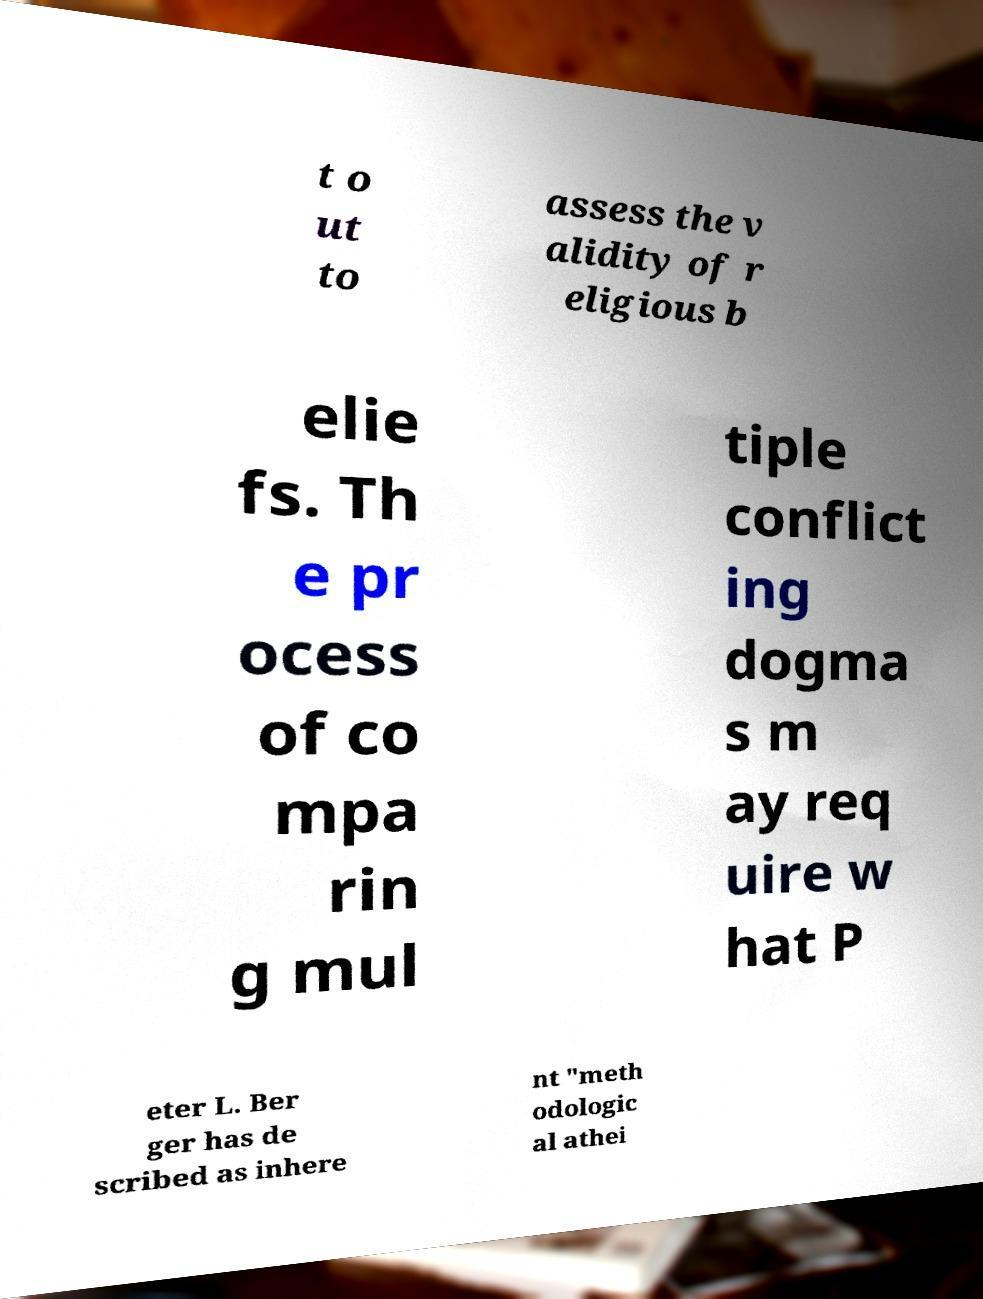Please read and relay the text visible in this image. What does it say? t o ut to assess the v alidity of r eligious b elie fs. Th e pr ocess of co mpa rin g mul tiple conflict ing dogma s m ay req uire w hat P eter L. Ber ger has de scribed as inhere nt "meth odologic al athei 